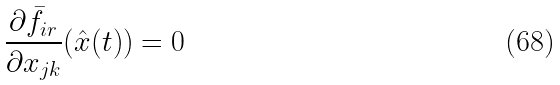Convert formula to latex. <formula><loc_0><loc_0><loc_500><loc_500>\frac { \partial \bar { f } _ { i r } } { \partial x _ { j k } } ( \hat { x } ( t ) ) = 0</formula> 